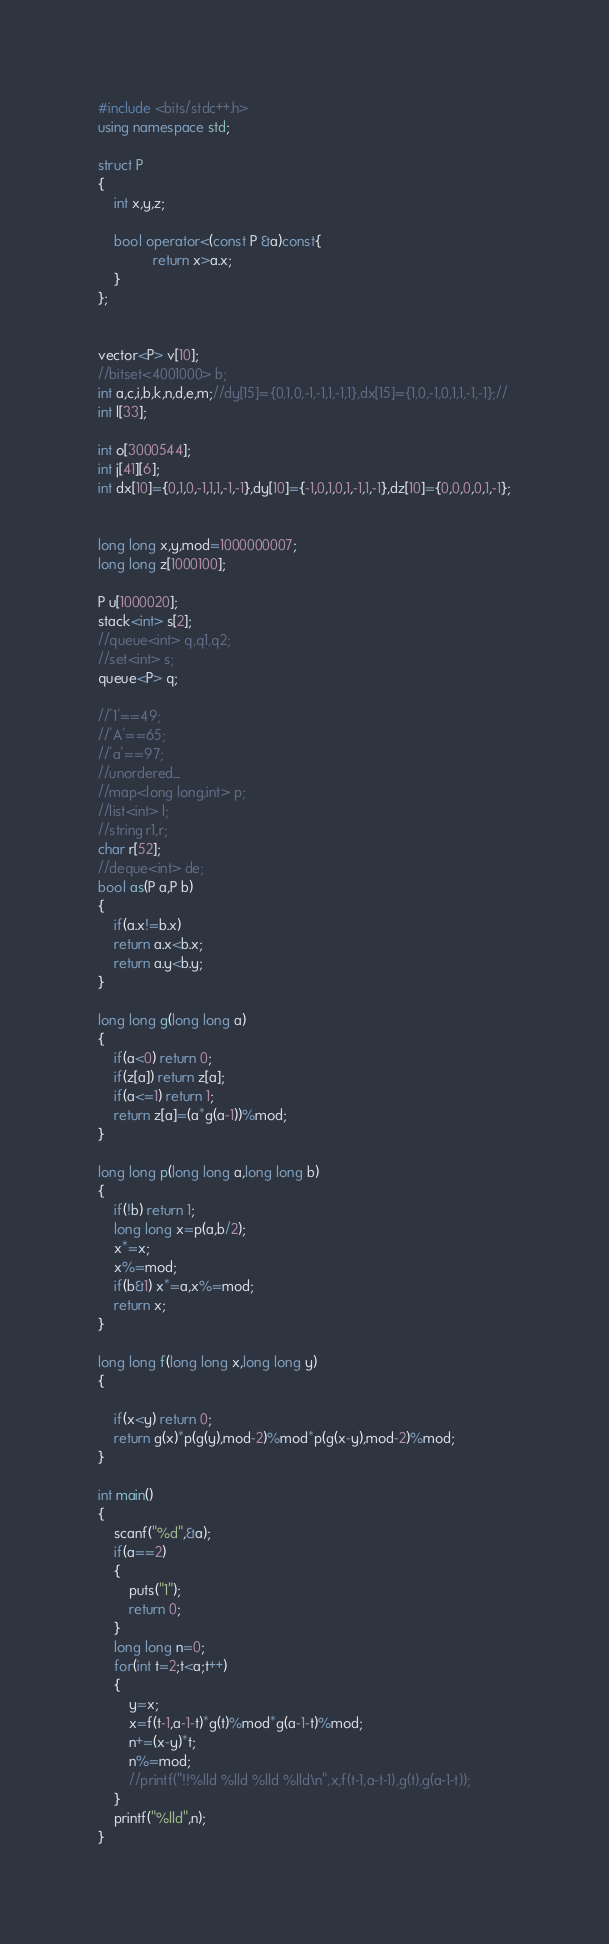Convert code to text. <code><loc_0><loc_0><loc_500><loc_500><_C++_>#include <bits/stdc++.h>
using namespace std;

struct P
{
    int x,y,z;

    bool operator<(const P &a)const{
              return x>a.x;
    }
};


vector<P> v[10];
//bitset<4001000> b;
int a,c,i,b,k,n,d,e,m;//dy[15]={0,1,0,-1,-1,1,-1,1},dx[15]={1,0,-1,0,1,1,-1,-1};//
int l[33];

int o[3000544];
int j[41][6];
int dx[10]={0,1,0,-1,1,1,-1,-1},dy[10]={-1,0,1,0,1,-1,1,-1},dz[10]={0,0,0,0,1,-1};


long long x,y,mod=1000000007;
long long z[1000100];

P u[1000020];
stack<int> s[2];
//queue<int> q,q1,q2;
//set<int> s;
queue<P> q;

//'1'==49;
//'A'==65;
//'a'==97;
//unordered_
//map<long long,int> p;
//list<int> l;
//string r1,r;
char r[52];
//deque<int> de;
bool as(P a,P b)
{
    if(a.x!=b.x)
    return a.x<b.x;
    return a.y<b.y;
}

long long g(long long a)
{
    if(a<0) return 0;
    if(z[a]) return z[a];
    if(a<=1) return 1;
    return z[a]=(a*g(a-1))%mod;
}

long long p(long long a,long long b)
{
    if(!b) return 1;
    long long x=p(a,b/2);
    x*=x;
    x%=mod;
    if(b&1) x*=a,x%=mod;
    return x;
}

long long f(long long x,long long y)
{

    if(x<y) return 0;
    return g(x)*p(g(y),mod-2)%mod*p(g(x-y),mod-2)%mod;
}

int main()
{
    scanf("%d",&a);
    if(a==2)
    {
        puts("1");
        return 0;
    }
    long long n=0;
    for(int t=2;t<a;t++)
    {
        y=x;
        x=f(t-1,a-1-t)*g(t)%mod*g(a-1-t)%mod;
        n+=(x-y)*t;
        n%=mod;
        //printf("!!%lld %lld %lld %lld\n",x,f(t-1,a-t-1),g(t),g(a-1-t));
    }
    printf("%lld",n);
}
</code> 